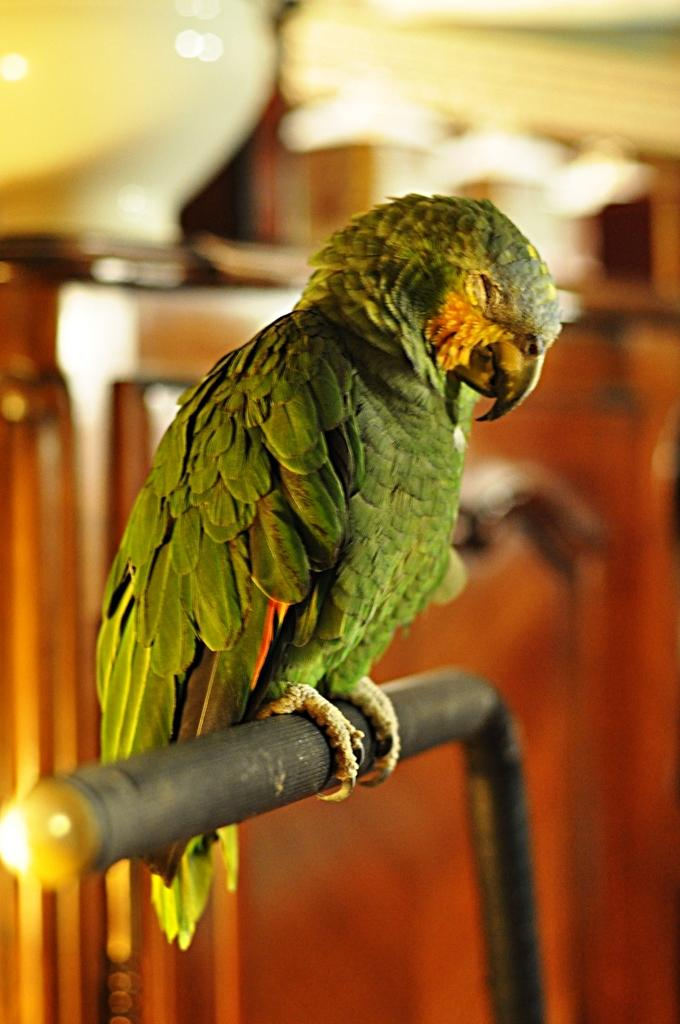What type of animal is in the image? There is a bird in the image. Can you describe the bird's appearance? The bird looks like a parrot and is green in color. What can be observed about the background of the image? The background of the image is blurred. Is the bear causing trouble at the camp in the image? There is no bear or camp present in the image; it features a green parrot-like bird. 